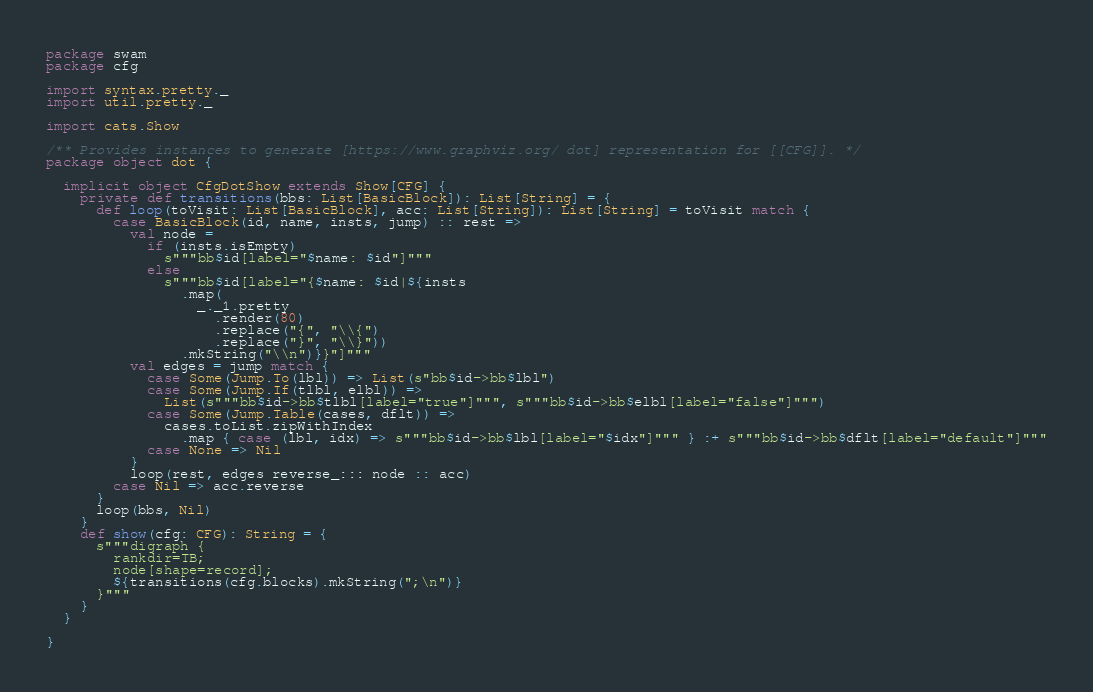<code> <loc_0><loc_0><loc_500><loc_500><_Scala_>package swam
package cfg

import syntax.pretty._
import util.pretty._

import cats.Show

/** Provides instances to generate [https://www.graphviz.org/ dot] representation for [[CFG]]. */
package object dot {

  implicit object CfgDotShow extends Show[CFG] {
    private def transitions(bbs: List[BasicBlock]): List[String] = {
      def loop(toVisit: List[BasicBlock], acc: List[String]): List[String] = toVisit match {
        case BasicBlock(id, name, insts, jump) :: rest =>
          val node =
            if (insts.isEmpty)
              s"""bb$id[label="$name: $id"]"""
            else
              s"""bb$id[label="{$name: $id|${insts
                .map(
                  _._1.pretty
                    .render(80)
                    .replace("{", "\\{")
                    .replace("}", "\\}"))
                .mkString("\\n")}}"]"""
          val edges = jump match {
            case Some(Jump.To(lbl)) => List(s"bb$id->bb$lbl")
            case Some(Jump.If(tlbl, elbl)) =>
              List(s"""bb$id->bb$tlbl[label="true"]""", s"""bb$id->bb$elbl[label="false"]""")
            case Some(Jump.Table(cases, dflt)) =>
              cases.toList.zipWithIndex
                .map { case (lbl, idx) => s"""bb$id->bb$lbl[label="$idx"]""" } :+ s"""bb$id->bb$dflt[label="default"]"""
            case None => Nil
          }
          loop(rest, edges reverse_::: node :: acc)
        case Nil => acc.reverse
      }
      loop(bbs, Nil)
    }
    def show(cfg: CFG): String = {
      s"""digraph {
        rankdir=TB;
        node[shape=record];
        ${transitions(cfg.blocks).mkString(";\n")}
      }"""
    }
  }

}
</code> 